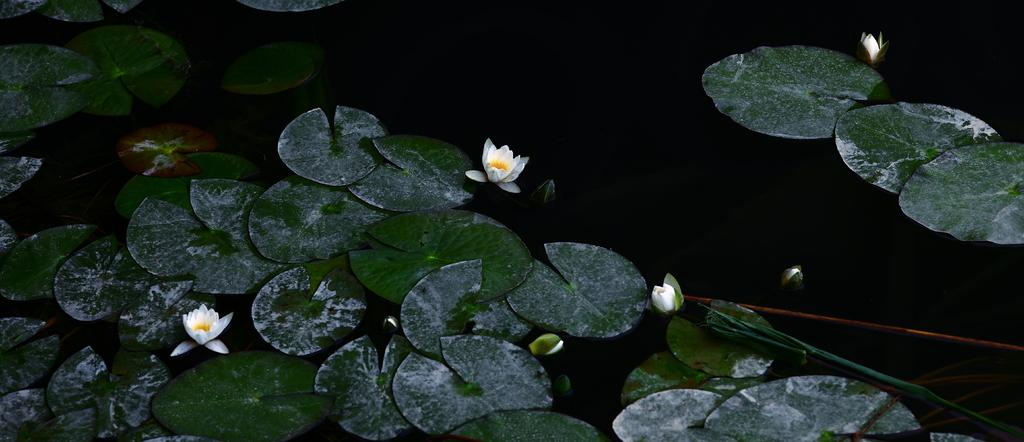What type of vegetation is present in the image? There are leaves and lotus flowers in the image. What is the relationship between the leaves and lotus flowers in the image? Both the leaves and lotus flowers are floating on the water. What time of day is it in the image, and how does the knot affect the afternoon? The time of day is not mentioned in the image, and there is no knot present. The afternoon is not affected by any knot in the image. 